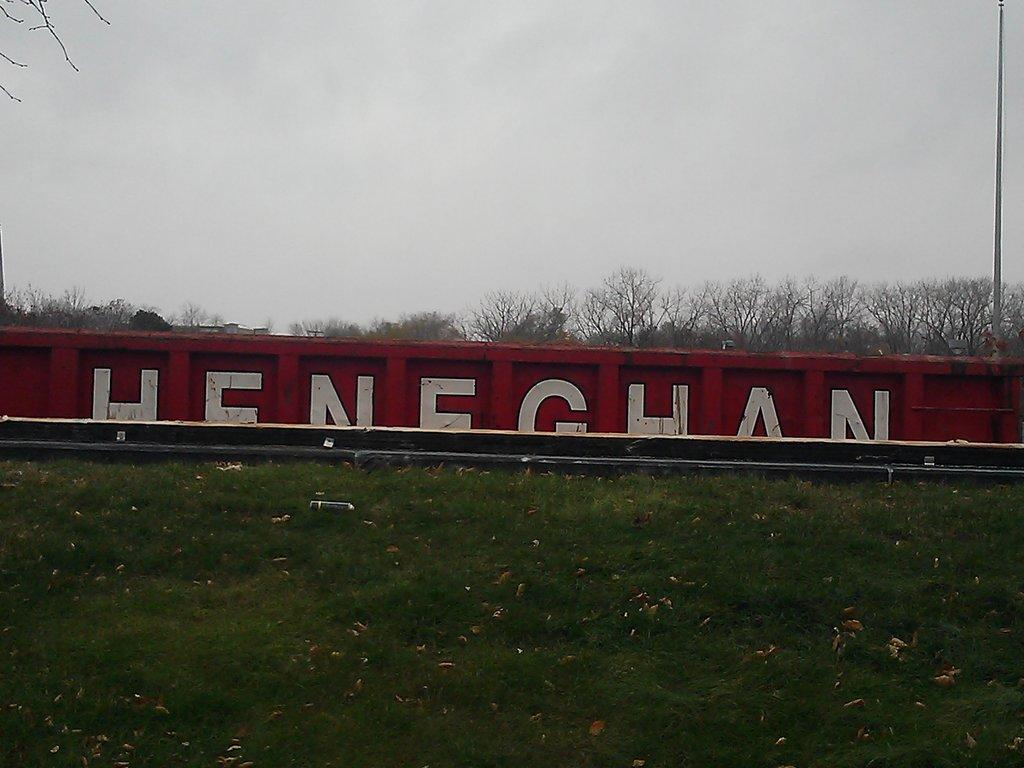<image>
Provide a brief description of the given image. The word Heneghan in white on a red background is half hidden by a hill. 